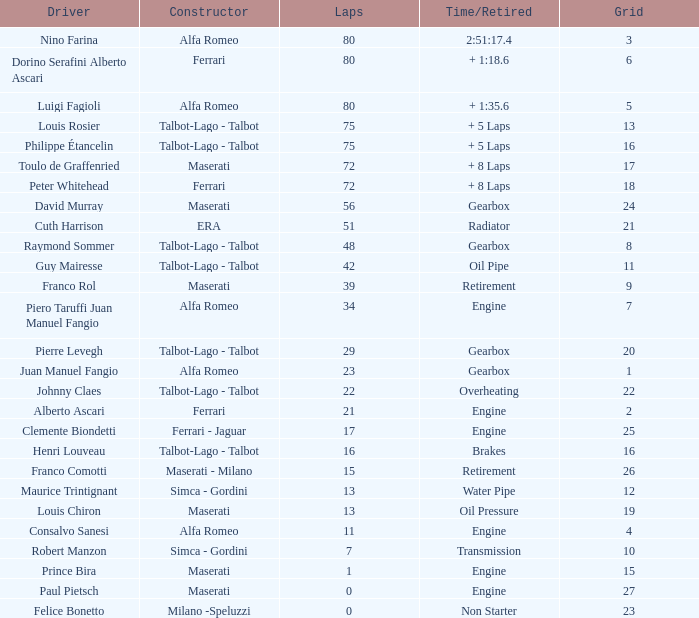What is the highest grid position when juan manuel fangio is the driver and completes less than 39 laps? 1.0. 